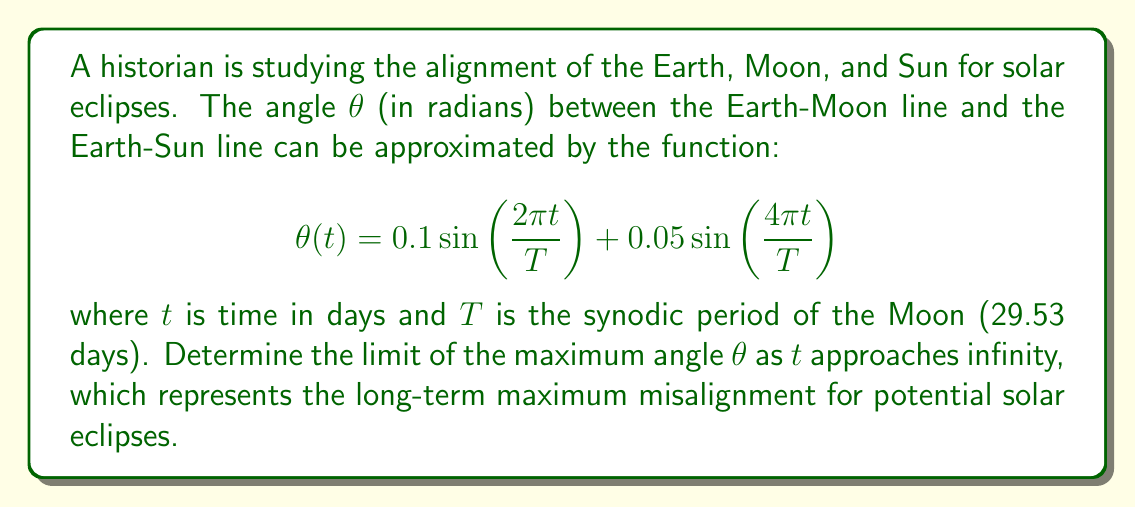Can you solve this math problem? To solve this problem, we'll follow these steps:

1) The function θ(t) is periodic with period T. As t approaches infinity, we're interested in the maximum value of this function over its period.

2) To find the maximum value, we need to find the critical points of θ(t) by taking its derivative and setting it to zero:

   $$θ'(t) = 0.1(2π/T)\cos(2πt/T) + 0.05(4π/T)\cos(4πt/T)$$

3) Setting θ'(t) = 0 gives us a transcendental equation that's difficult to solve analytically. However, we don't need to solve it exactly for our purpose.

4) Instead, we can observe that the maximum value of θ(t) will occur when both sine terms in the original function are at their maximum simultaneously.

5) The maximum value of sine is 1, which occurs when its argument is π/2 + 2πn for any integer n.

6) Therefore, the maximum value of θ(t) will be:

   $$θ_max = 0.1 * 1 + 0.05 * 1 = 0.15$$

7) This maximum value is independent of t, so as t approaches infinity, the limit of the maximum angle remains 0.15 radians.
Answer: 0.15 radians 